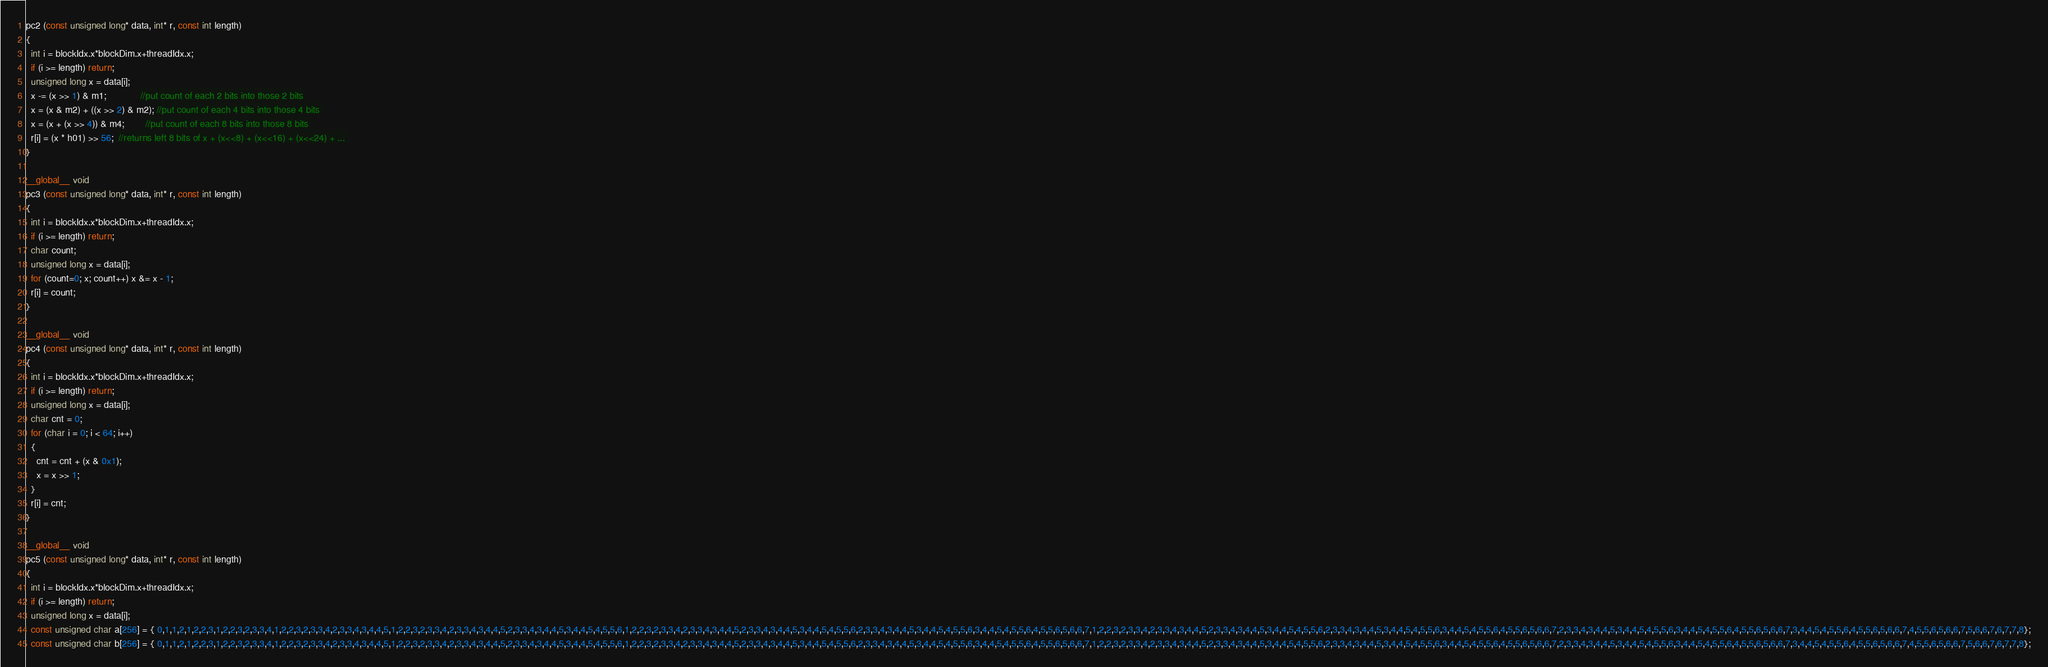Convert code to text. <code><loc_0><loc_0><loc_500><loc_500><_Cuda_>pc2 (const unsigned long* data, int* r, const int length)
{
  int i = blockIdx.x*blockDim.x+threadIdx.x;
  if (i >= length) return;
  unsigned long x = data[i];
  x -= (x >> 1) & m1;             //put count of each 2 bits into those 2 bits
  x = (x & m2) + ((x >> 2) & m2); //put count of each 4 bits into those 4 bits 
  x = (x + (x >> 4)) & m4;        //put count of each 8 bits into those 8 bits 
  r[i] = (x * h01) >> 56;  //returns left 8 bits of x + (x<<8) + (x<<16) + (x<<24) + ... 
}

__global__ void
pc3 (const unsigned long* data, int* r, const int length)
{
  int i = blockIdx.x*blockDim.x+threadIdx.x;
  if (i >= length) return;
  char count;
  unsigned long x = data[i];
  for (count=0; x; count++) x &= x - 1;
  r[i] = count;
}

__global__ void
pc4 (const unsigned long* data, int* r, const int length)
{
  int i = blockIdx.x*blockDim.x+threadIdx.x;
  if (i >= length) return;
  unsigned long x = data[i];
  char cnt = 0;
  for (char i = 0; i < 64; i++)
  {
    cnt = cnt + (x & 0x1);
    x = x >> 1;
  }
  r[i] = cnt;
}

__global__ void
pc5 (const unsigned long* data, int* r, const int length)
{
  int i = blockIdx.x*blockDim.x+threadIdx.x;
  if (i >= length) return;
  unsigned long x = data[i];
  const unsigned char a[256] = { 0,1,1,2,1,2,2,3,1,2,2,3,2,3,3,4,1,2,2,3,2,3,3,4,2,3,3,4,3,4,4,5,1,2,2,3,2,3,3,4,2,3,3,4,3,4,4,5,2,3,3,4,3,4,4,5,3,4,4,5,4,5,5,6,1,2,2,3,2,3,3,4,2,3,3,4,3,4,4,5,2,3,3,4,3,4,4,5,3,4,4,5,4,5,5,6,2,3,3,4,3,4,4,5,3,4,4,5,4,5,5,6,3,4,4,5,4,5,5,6,4,5,5,6,5,6,6,7,1,2,2,3,2,3,3,4,2,3,3,4,3,4,4,5,2,3,3,4,3,4,4,5,3,4,4,5,4,5,5,6,2,3,3,4,3,4,4,5,3,4,4,5,4,5,5,6,3,4,4,5,4,5,5,6,4,5,5,6,5,6,6,7,2,3,3,4,3,4,4,5,3,4,4,5,4,5,5,6,3,4,4,5,4,5,5,6,4,5,5,6,5,6,6,7,3,4,4,5,4,5,5,6,4,5,5,6,5,6,6,7,4,5,5,6,5,6,6,7,5,6,6,7,6,7,7,8};
  const unsigned char b[256] = { 0,1,1,2,1,2,2,3,1,2,2,3,2,3,3,4,1,2,2,3,2,3,3,4,2,3,3,4,3,4,4,5,1,2,2,3,2,3,3,4,2,3,3,4,3,4,4,5,2,3,3,4,3,4,4,5,3,4,4,5,4,5,5,6,1,2,2,3,2,3,3,4,2,3,3,4,3,4,4,5,2,3,3,4,3,4,4,5,3,4,4,5,4,5,5,6,2,3,3,4,3,4,4,5,3,4,4,5,4,5,5,6,3,4,4,5,4,5,5,6,4,5,5,6,5,6,6,7,1,2,2,3,2,3,3,4,2,3,3,4,3,4,4,5,2,3,3,4,3,4,4,5,3,4,4,5,4,5,5,6,2,3,3,4,3,4,4,5,3,4,4,5,4,5,5,6,3,4,4,5,4,5,5,6,4,5,5,6,5,6,6,7,2,3,3,4,3,4,4,5,3,4,4,5,4,5,5,6,3,4,4,5,4,5,5,6,4,5,5,6,5,6,6,7,3,4,4,5,4,5,5,6,4,5,5,6,5,6,6,7,4,5,5,6,5,6,6,7,5,6,6,7,6,7,7,8};</code> 